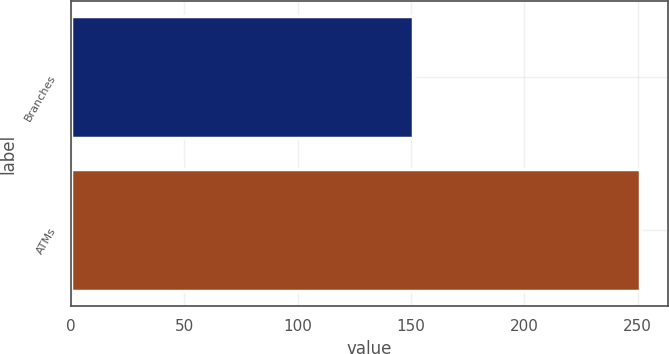<chart> <loc_0><loc_0><loc_500><loc_500><bar_chart><fcel>Branches<fcel>ATMs<nl><fcel>151<fcel>251<nl></chart> 